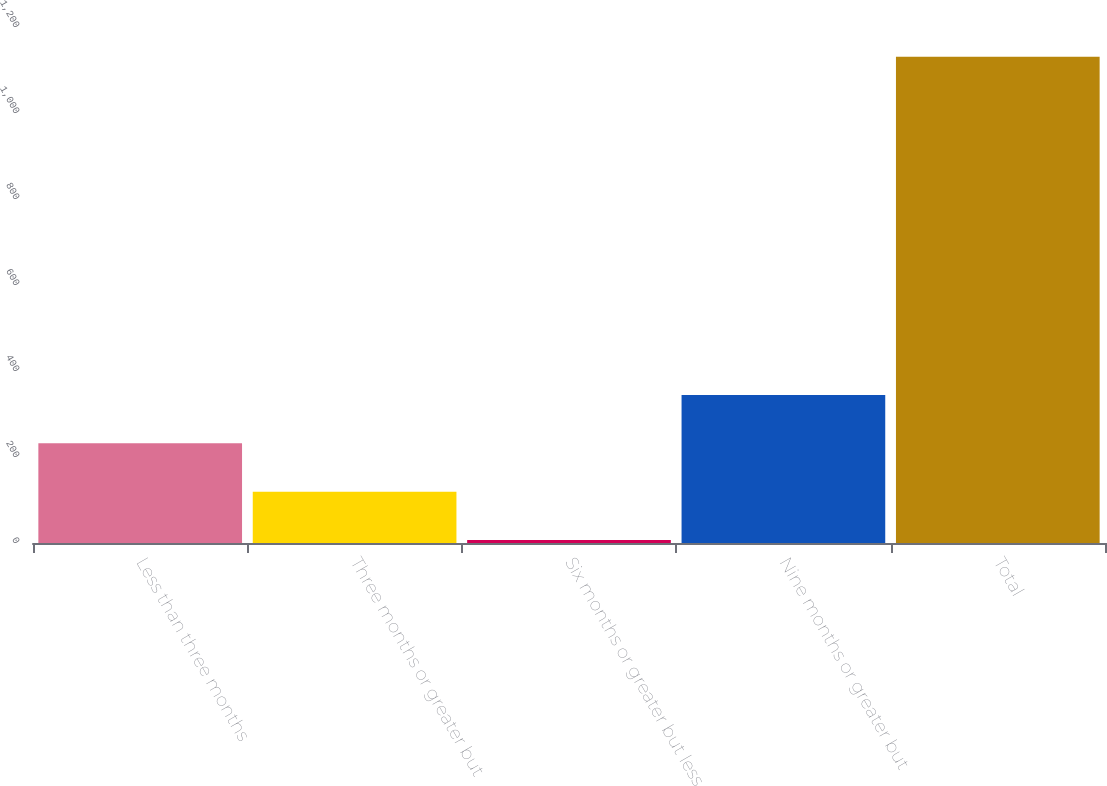Convert chart to OTSL. <chart><loc_0><loc_0><loc_500><loc_500><bar_chart><fcel>Less than three months<fcel>Three months or greater but<fcel>Six months or greater but less<fcel>Nine months or greater but<fcel>Total<nl><fcel>231.8<fcel>119.4<fcel>7<fcel>344.2<fcel>1131<nl></chart> 